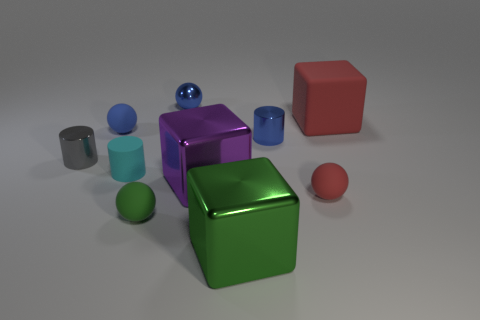Subtract 1 spheres. How many spheres are left? 3 Subtract all red spheres. How many spheres are left? 3 Subtract all blue shiny spheres. How many spheres are left? 3 Subtract all gray balls. Subtract all purple cubes. How many balls are left? 4 Subtract all blocks. How many objects are left? 7 Add 4 tiny green rubber things. How many tiny green rubber things exist? 5 Subtract 0 yellow cylinders. How many objects are left? 10 Subtract all big matte balls. Subtract all small green spheres. How many objects are left? 9 Add 2 big purple metal objects. How many big purple metal objects are left? 3 